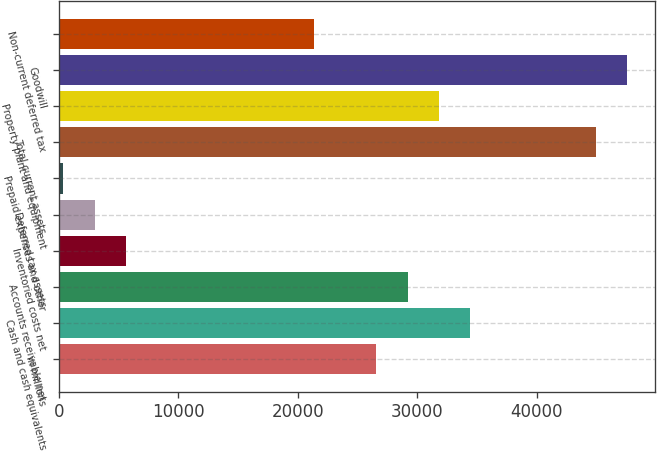Convert chart. <chart><loc_0><loc_0><loc_500><loc_500><bar_chart><fcel>in millions<fcel>Cash and cash equivalents<fcel>Accounts receivable net<fcel>Inventoried costs net<fcel>Deferred tax assets<fcel>Prepaid expenses and other<fcel>Total current assets<fcel>Property plant and equipment<fcel>Goodwill<fcel>Non-current deferred tax<nl><fcel>26572<fcel>34432.9<fcel>29192.3<fcel>5609.6<fcel>2989.3<fcel>369<fcel>44914.1<fcel>31812.6<fcel>47534.4<fcel>21331.4<nl></chart> 